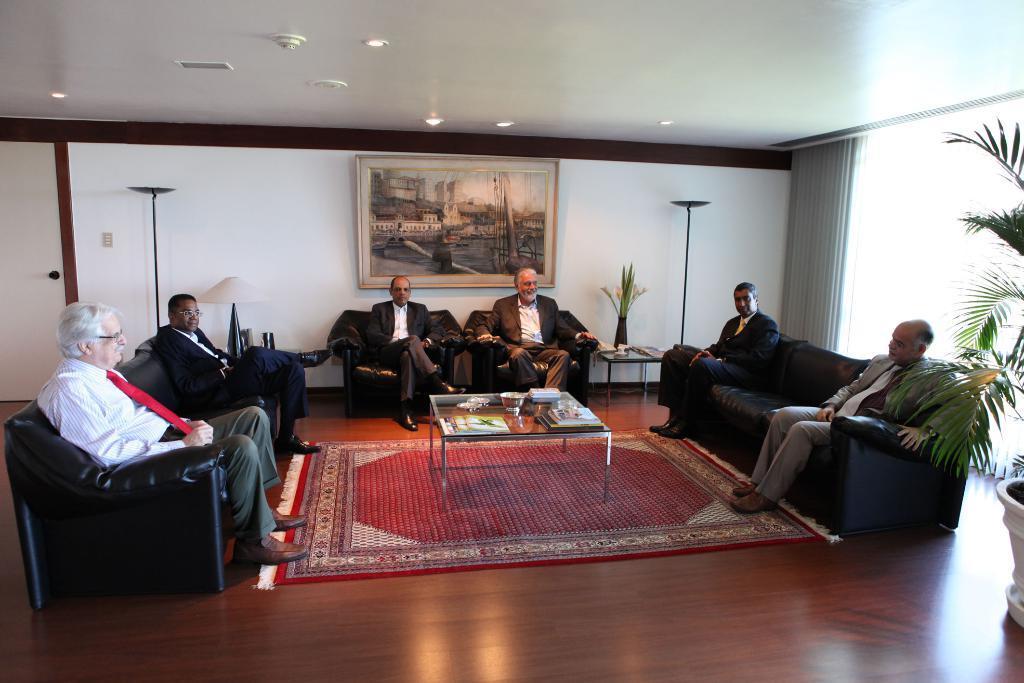Could you give a brief overview of what you see in this image? This picture we can see some people are sitting and talking with each other in between them there is a table on table there are some books and some bolus are being placed back side we can see the wall on the wall there is a photo frame in the left corner of the picture we can see the potted plant. 